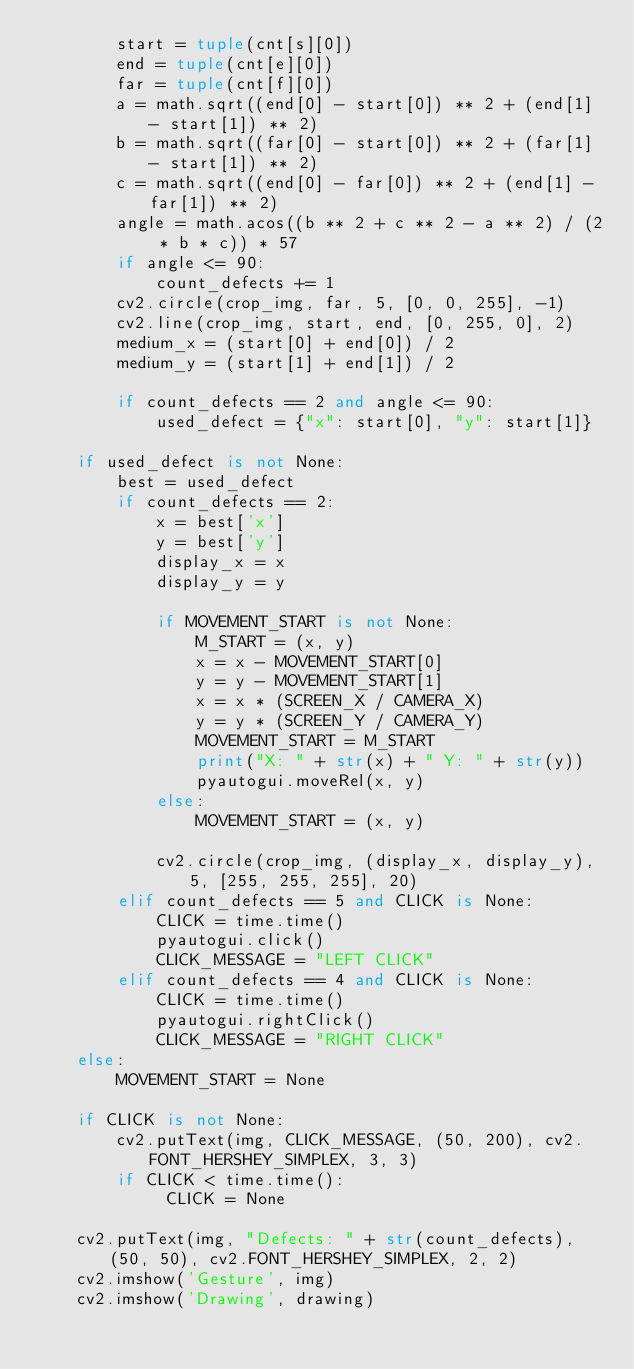Convert code to text. <code><loc_0><loc_0><loc_500><loc_500><_Python_>        start = tuple(cnt[s][0])
        end = tuple(cnt[e][0])
        far = tuple(cnt[f][0])
        a = math.sqrt((end[0] - start[0]) ** 2 + (end[1] - start[1]) ** 2)
        b = math.sqrt((far[0] - start[0]) ** 2 + (far[1] - start[1]) ** 2)
        c = math.sqrt((end[0] - far[0]) ** 2 + (end[1] - far[1]) ** 2)
        angle = math.acos((b ** 2 + c ** 2 - a ** 2) / (2 * b * c)) * 57
        if angle <= 90:
            count_defects += 1
        cv2.circle(crop_img, far, 5, [0, 0, 255], -1)
        cv2.line(crop_img, start, end, [0, 255, 0], 2)
        medium_x = (start[0] + end[0]) / 2
        medium_y = (start[1] + end[1]) / 2

        if count_defects == 2 and angle <= 90:
            used_defect = {"x": start[0], "y": start[1]}

    if used_defect is not None:
        best = used_defect
        if count_defects == 2:
            x = best['x']
            y = best['y']
            display_x = x
            display_y = y

            if MOVEMENT_START is not None:
                M_START = (x, y)
                x = x - MOVEMENT_START[0]
                y = y - MOVEMENT_START[1]
                x = x * (SCREEN_X / CAMERA_X)
                y = y * (SCREEN_Y / CAMERA_Y)
                MOVEMENT_START = M_START
                print("X: " + str(x) + " Y: " + str(y))
                pyautogui.moveRel(x, y)
            else:
                MOVEMENT_START = (x, y)

            cv2.circle(crop_img, (display_x, display_y), 5, [255, 255, 255], 20)
        elif count_defects == 5 and CLICK is None:
            CLICK = time.time()
            pyautogui.click()
            CLICK_MESSAGE = "LEFT CLICK"
        elif count_defects == 4 and CLICK is None:
            CLICK = time.time()
            pyautogui.rightClick()
            CLICK_MESSAGE = "RIGHT CLICK"
    else:
        MOVEMENT_START = None

    if CLICK is not None:
        cv2.putText(img, CLICK_MESSAGE, (50, 200), cv2.FONT_HERSHEY_SIMPLEX, 3, 3)
        if CLICK < time.time():
             CLICK = None

    cv2.putText(img, "Defects: " + str(count_defects), (50, 50), cv2.FONT_HERSHEY_SIMPLEX, 2, 2)
    cv2.imshow('Gesture', img)
    cv2.imshow('Drawing', drawing)
</code> 